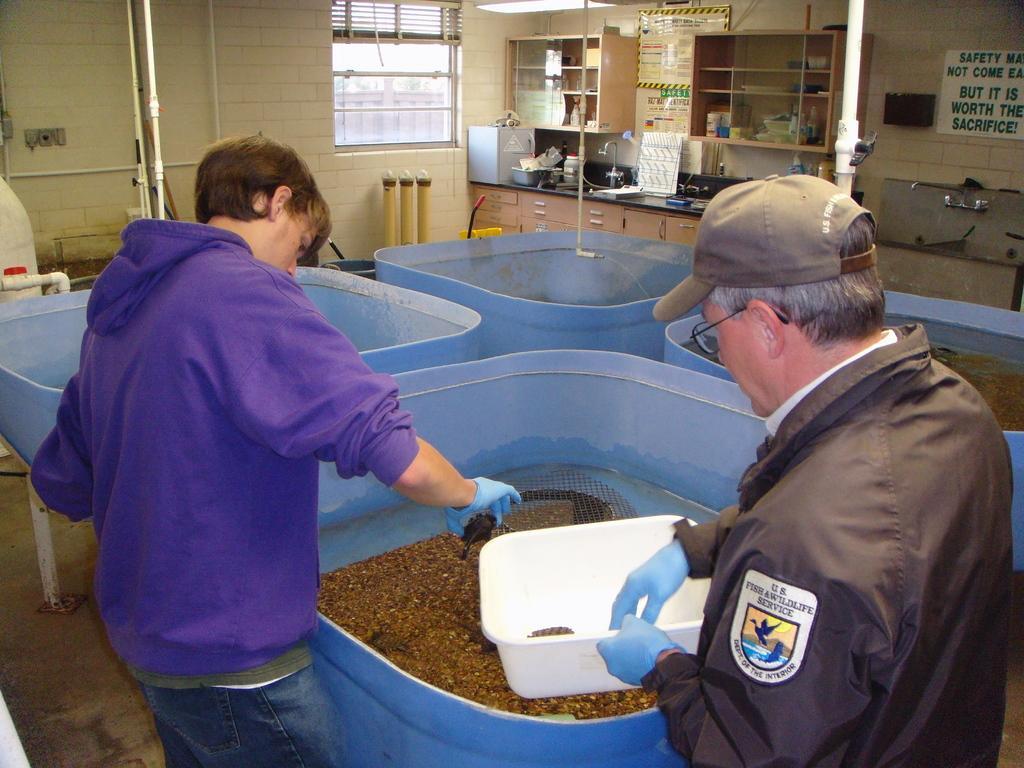Describe this image in one or two sentences. This image is taken indoors. In the background there is a wall with a window and there is a window blind. There are a few pipes. There are a few cupboards with shelves and there are many things on the shelves. There is a kitchen platform with many things on it. There is a board with a text on it. On the left side of the image there is a pipe. There is a tub and a boy is standing and he is holding an object in his hands. In the middle of the image there are a few tubs with a few things in them. On the right side of the image a man is standing and he is holding a bowl in his hands. 